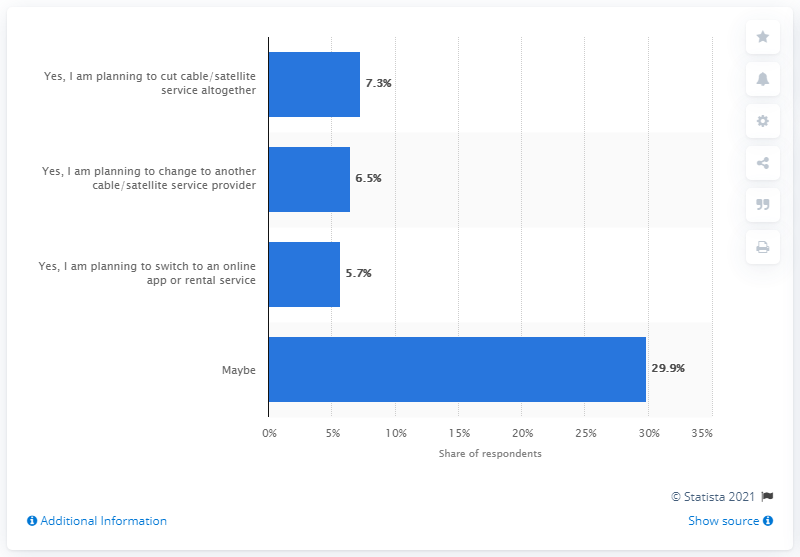Identify some key points in this picture. According to the survey, 5.7% of respondents stated that they are planning to switch to an online app or rental service in the next six months. 